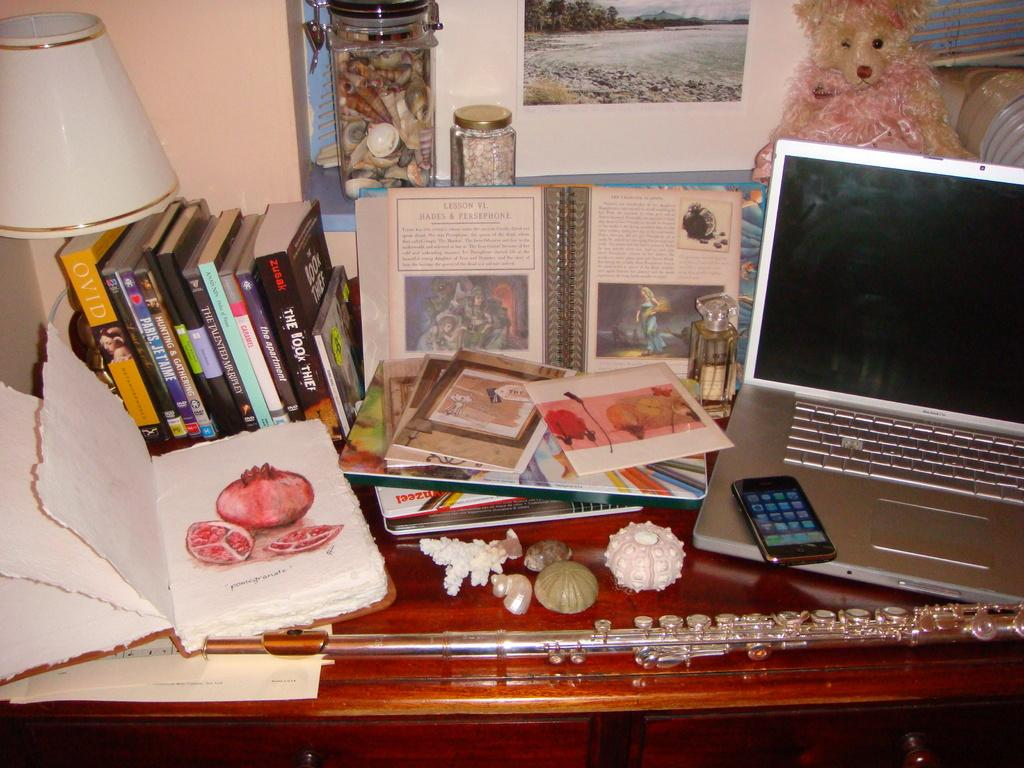What is the main piece of furniture in the image? There is a table in the image. What items can be seen on the table? There are books, a bottle, a laptop, a mobile, shells, toys, and a stick on the table. What is located near the table? There is a rack in the image. What can be found on the rack? There are jars on the rack. What can be seen in the background of the image? There is a wall with photos in the background. What type of list is hanging on the wall in the image? There is no list hanging on the wall in the image; it features photos instead. What unit of measurement is used to describe the size of the stick on the table? The provided facts do not include any information about the size or unit of measurement for the stick on the table. 